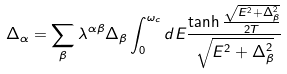<formula> <loc_0><loc_0><loc_500><loc_500>\Delta _ { \alpha } = \sum _ { \beta } \lambda ^ { \alpha \beta } \Delta _ { \beta } \int _ { 0 } ^ { \omega _ { c } } d E \frac { \tanh \frac { \sqrt { E ^ { 2 } + \Delta _ { \beta } ^ { 2 } } } { 2 T } } { \sqrt { E ^ { 2 } + \Delta _ { \beta } ^ { 2 } } }</formula> 